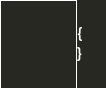Convert code to text. <code><loc_0><loc_0><loc_500><loc_500><_PHP_>{
}
</code> 